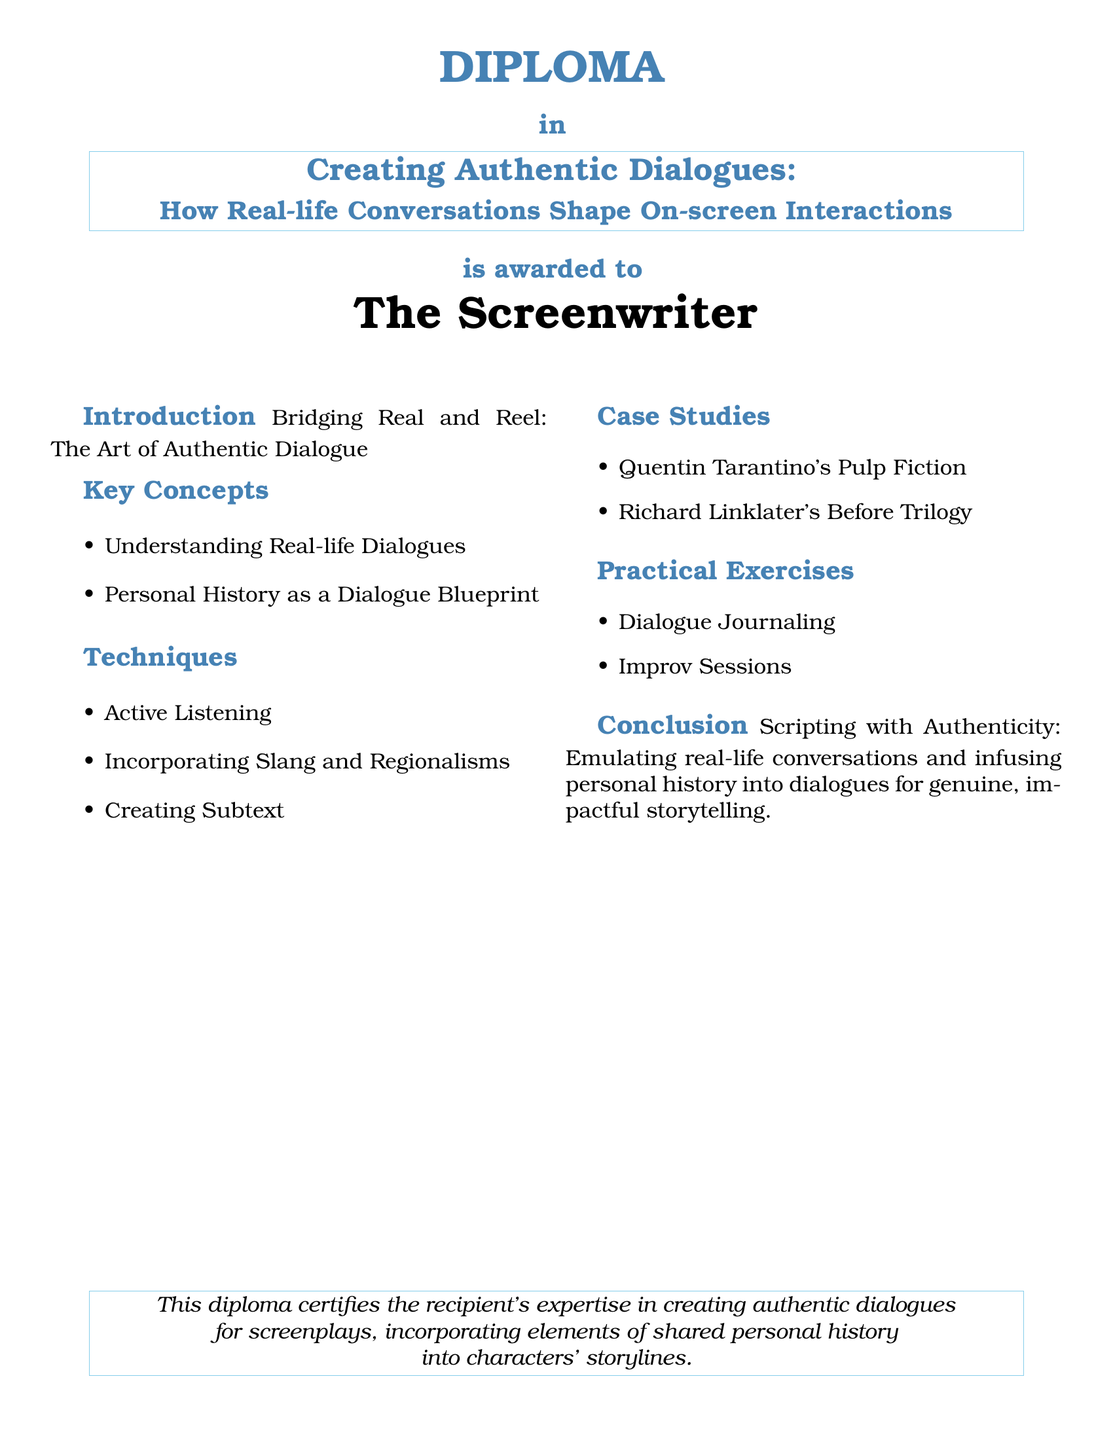What is the title of the diploma? The title of the diploma is "Creating Authentic Dialogues: How Real-life Conversations Shape On-screen Interactions."
Answer: Creating Authentic Dialogues: How Real-life Conversations Shape On-screen Interactions Who is the recipient of the diploma? The document specifies that the diploma is awarded to "The Screenwriter."
Answer: The Screenwriter What are the two key concepts listed in the document? The key concepts mentioned are "Understanding Real-life Dialogues" and "Personal History as a Dialogue Blueprint."
Answer: Understanding Real-life Dialogues, Personal History as a Dialogue Blueprint Name one case study mentioned in the document. The document includes case studies such as "Quentin Tarantino's Pulp Fiction" and "Richard Linklater's Before Trilogy."
Answer: Quentin Tarantino's Pulp Fiction What practical exercise involves improvisation? The document lists "Improv Sessions" as a practical exercise, which is linked to improvisation.
Answer: Improv Sessions What is the conclusion's emphasis in the document? The conclusion emphasizes "Scripting with Authenticity" and the importance of infusing personal history into dialogues for storytelling.
Answer: Scripting with Authenticity How many practical exercises are mentioned? The document states two exercises under practical exercises, which are "Dialogue Journaling" and "Improv Sessions."
Answer: Two What color is used for the title text? The title text is colored in a shade described as "titlecolor," which is defined in RGB.
Answer: Titlecolor 